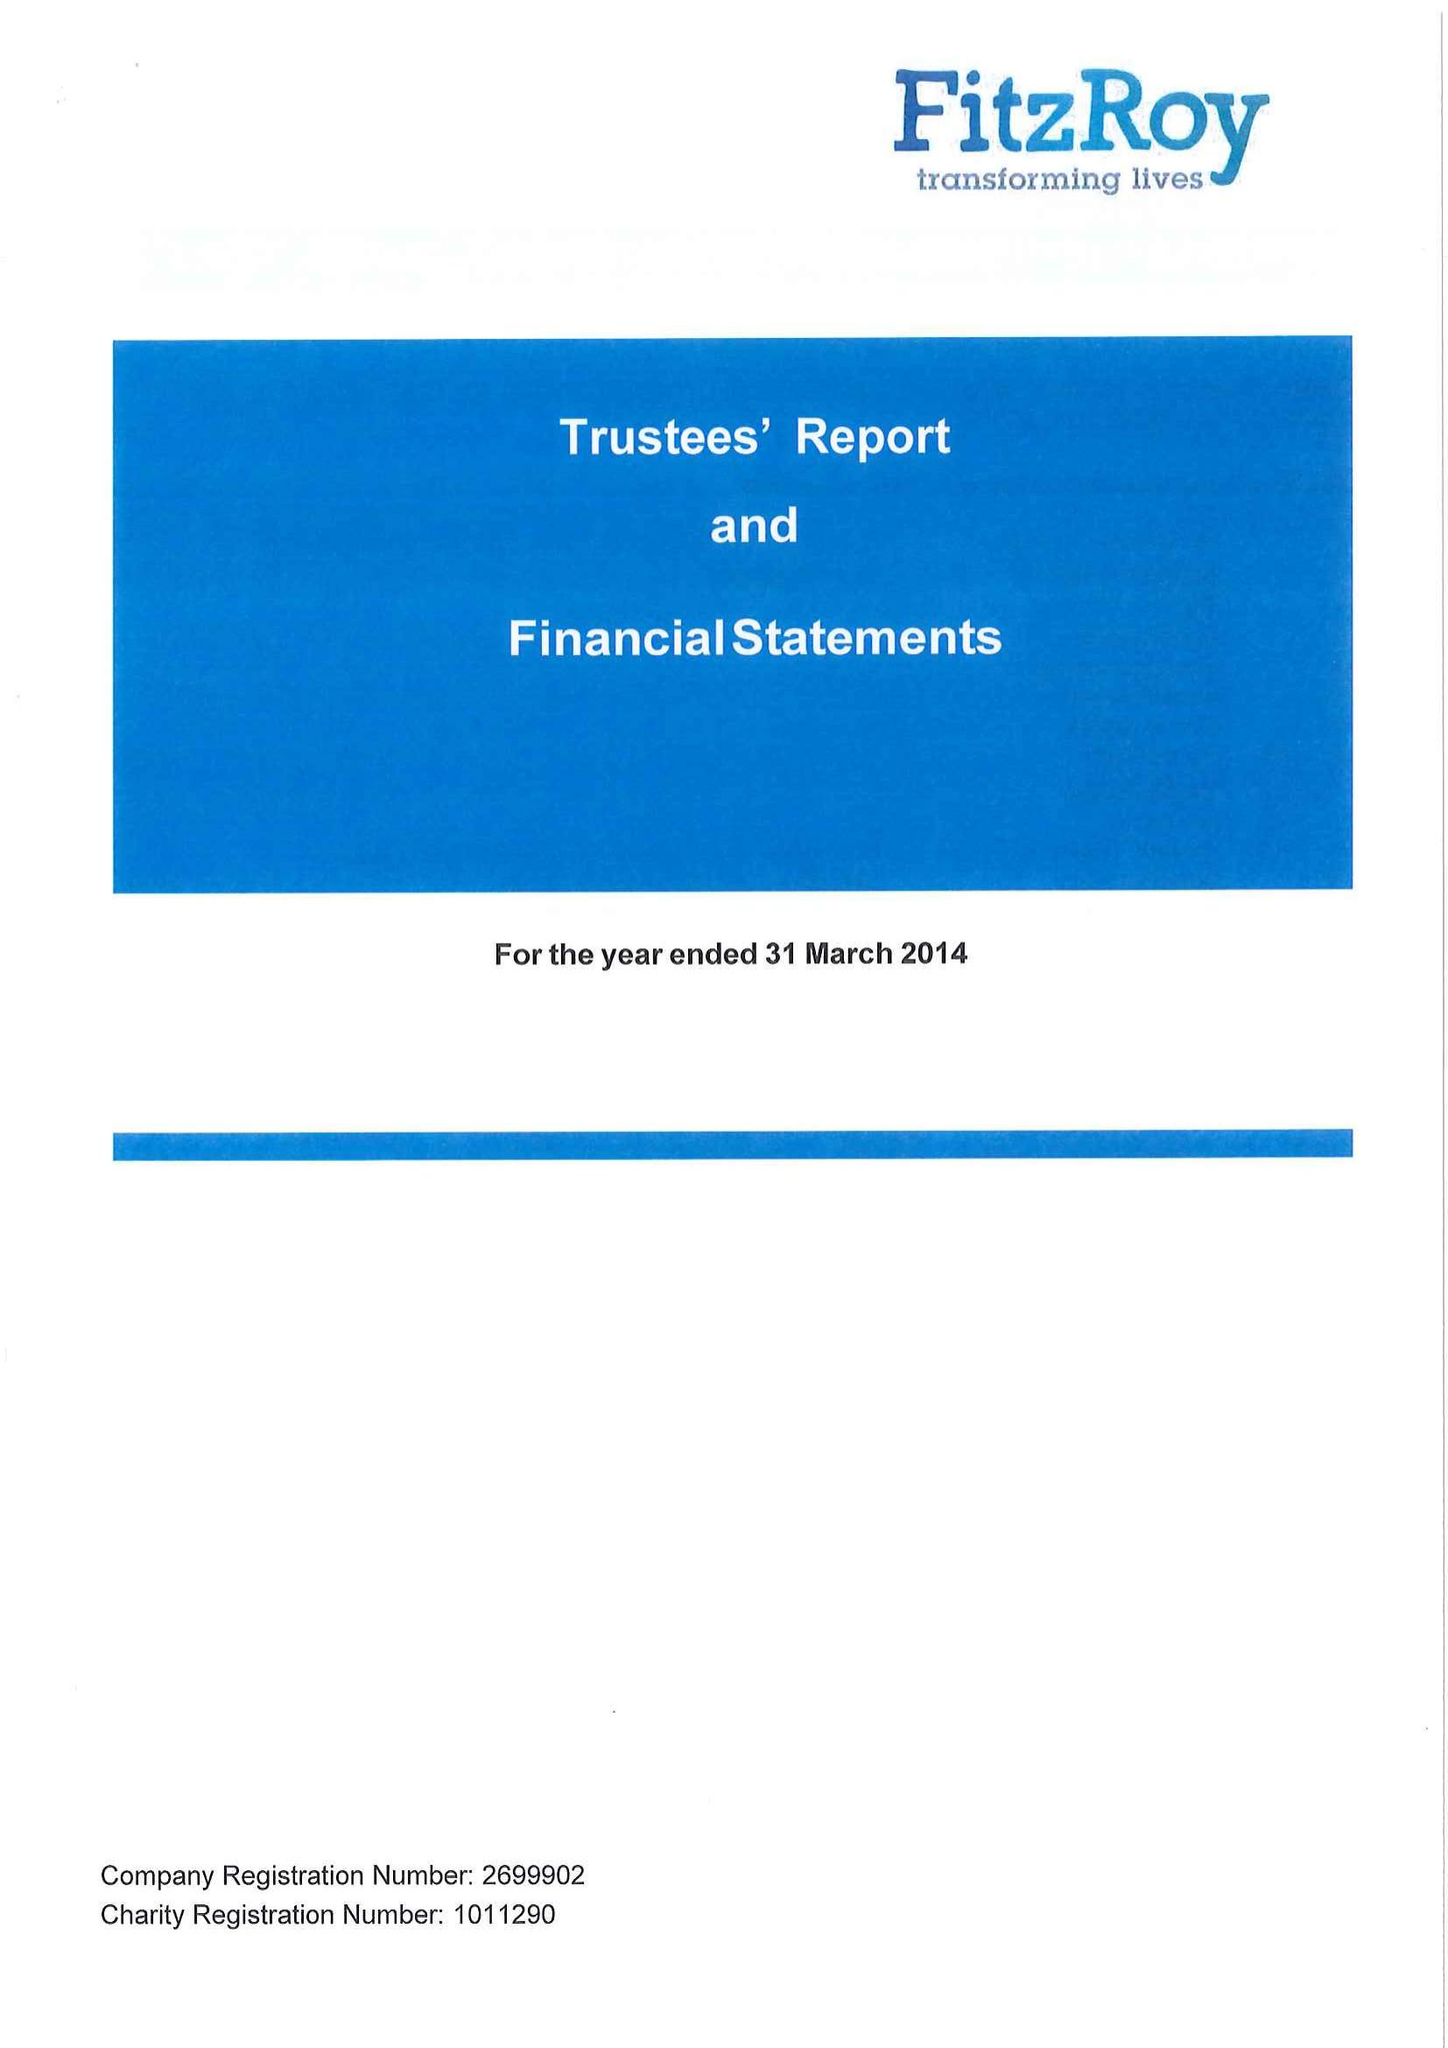What is the value for the income_annually_in_british_pounds?
Answer the question using a single word or phrase. 22352413.00 